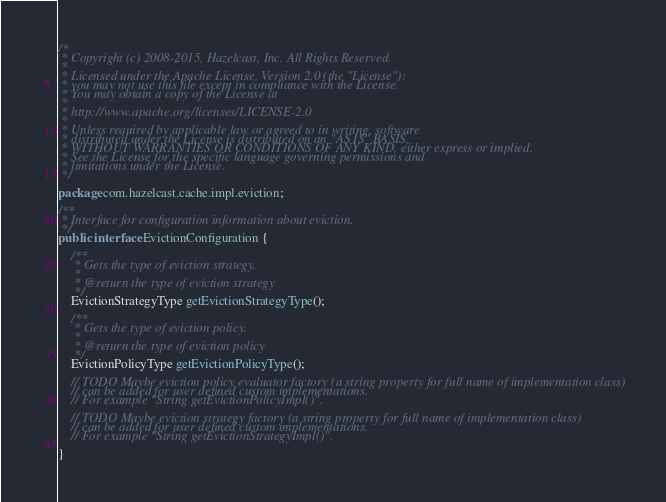Convert code to text. <code><loc_0><loc_0><loc_500><loc_500><_Java_>/*
 * Copyright (c) 2008-2015, Hazelcast, Inc. All Rights Reserved.
 *
 * Licensed under the Apache License, Version 2.0 (the "License");
 * you may not use this file except in compliance with the License.
 * You may obtain a copy of the License at
 *
 * http://www.apache.org/licenses/LICENSE-2.0
 *
 * Unless required by applicable law or agreed to in writing, software
 * distributed under the License is distributed on an "AS IS" BASIS,
 * WITHOUT WARRANTIES OR CONDITIONS OF ANY KIND, either express or implied.
 * See the License for the specific language governing permissions and
 * limitations under the License.
 */

package com.hazelcast.cache.impl.eviction;

/**
 * Interface for configuration information about eviction.
 */
public interface EvictionConfiguration {

    /**
     * Gets the type of eviction strategy.
     *
     * @return the type of eviction strategy
     */
    EvictionStrategyType getEvictionStrategyType();

    /**
     * Gets the type of eviction policy.
     *
     * @return the type of eviction policy
     */
    EvictionPolicyType getEvictionPolicyType();

    // TODO Maybe eviction policy evaluator factory (a string property for full name of implementation class)
    // can be added for user defined custom implementations.
    // For example "String getEvictionPolicyImpl()".

    // TODO Maybe eviction strategy factory (a string property for full name of implementation class)
    // can be added for user defined custom implementations.
    // For example "String getEvictionStrategyImpl()".

}
</code> 